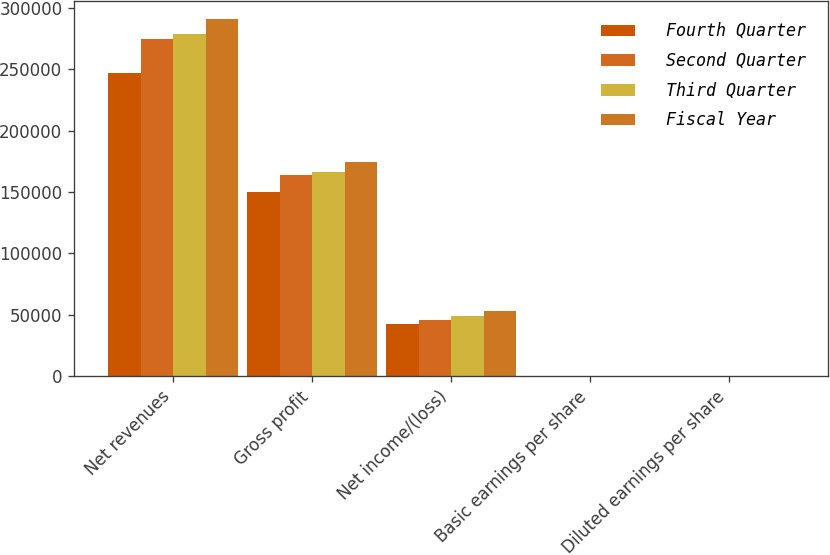Convert chart. <chart><loc_0><loc_0><loc_500><loc_500><stacked_bar_chart><ecel><fcel>Net revenues<fcel>Gross profit<fcel>Net income/(loss)<fcel>Basic earnings per share<fcel>Diluted earnings per share<nl><fcel>Fourth Quarter<fcel>246992<fcel>150178<fcel>42102<fcel>0.56<fcel>0.55<nl><fcel>Second Quarter<fcel>275134<fcel>164205<fcel>45983<fcel>0.61<fcel>0.6<nl><fcel>Third Quarter<fcel>278659<fcel>166583<fcel>48834<fcel>0.65<fcel>0.63<nl><fcel>Fiscal Year<fcel>291572<fcel>174517<fcel>53166<fcel>0.7<fcel>0.68<nl></chart> 